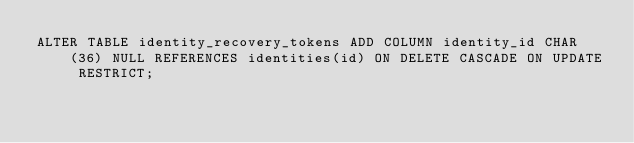<code> <loc_0><loc_0><loc_500><loc_500><_SQL_>ALTER TABLE identity_recovery_tokens ADD COLUMN identity_id CHAR(36) NULL REFERENCES identities(id) ON DELETE CASCADE ON UPDATE RESTRICT;</code> 